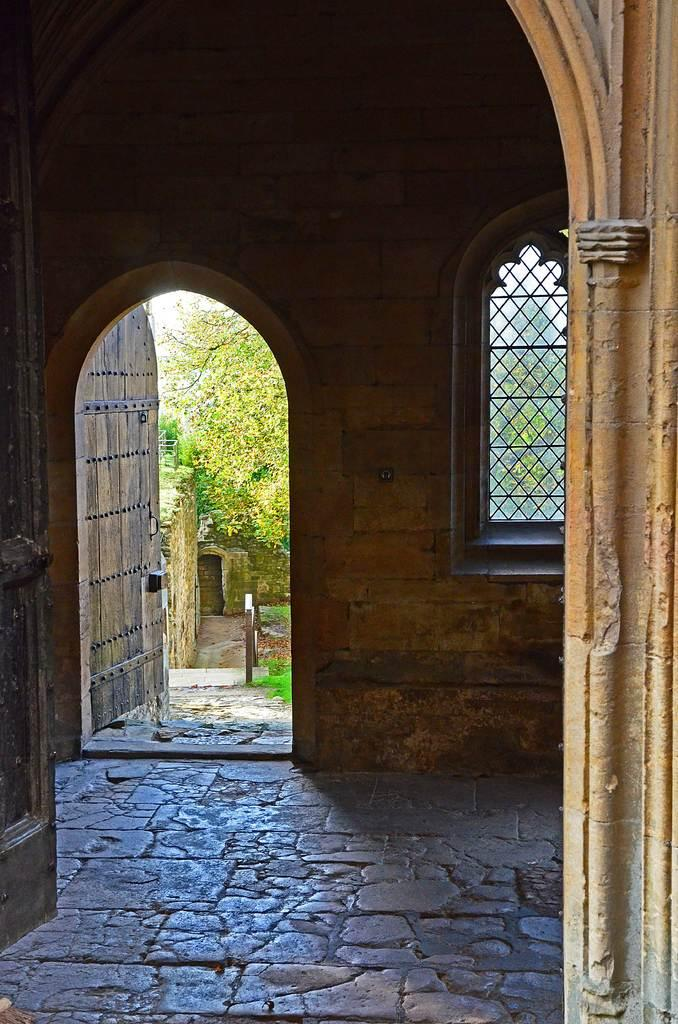What type of location is depicted in the image? The image shows an inside view of a building. Can you describe the background of the image? There are trees visible in the background of the image. What type of plot is being discussed in the image? There is no plot being discussed in the image, as it shows an inside view of a building and trees in the background. What kind of furniture can be seen in the image? There is no furniture visible in the image; it only shows an inside view of a building and trees in the background. 